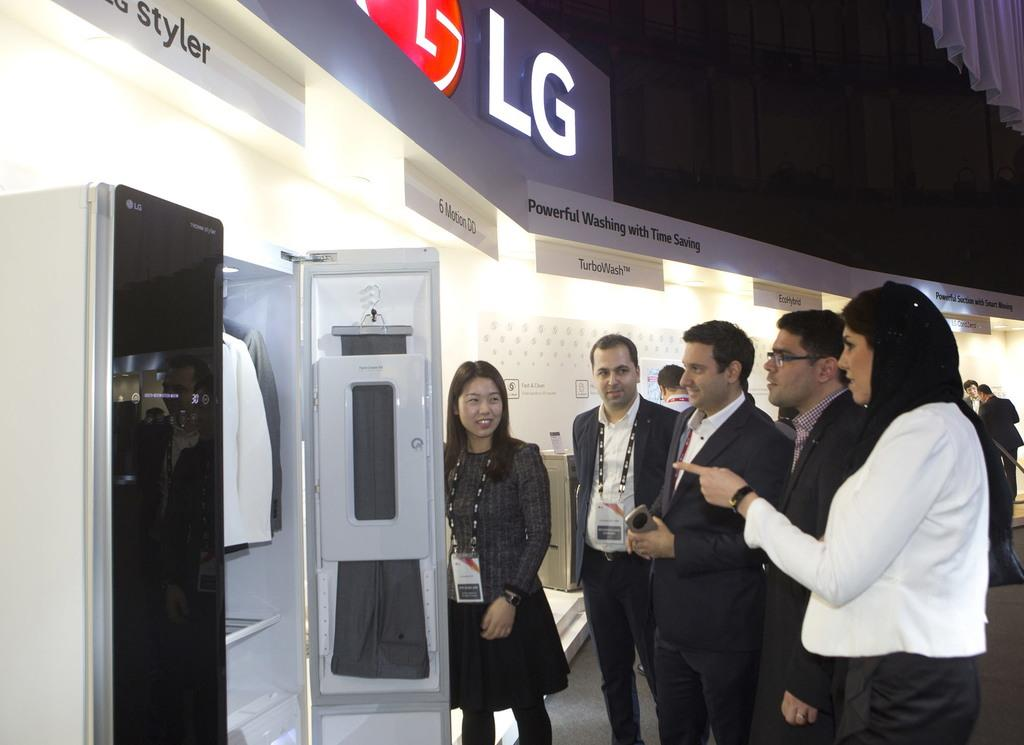<image>
Describe the image concisely. A group of people stand in front of an LG display. 